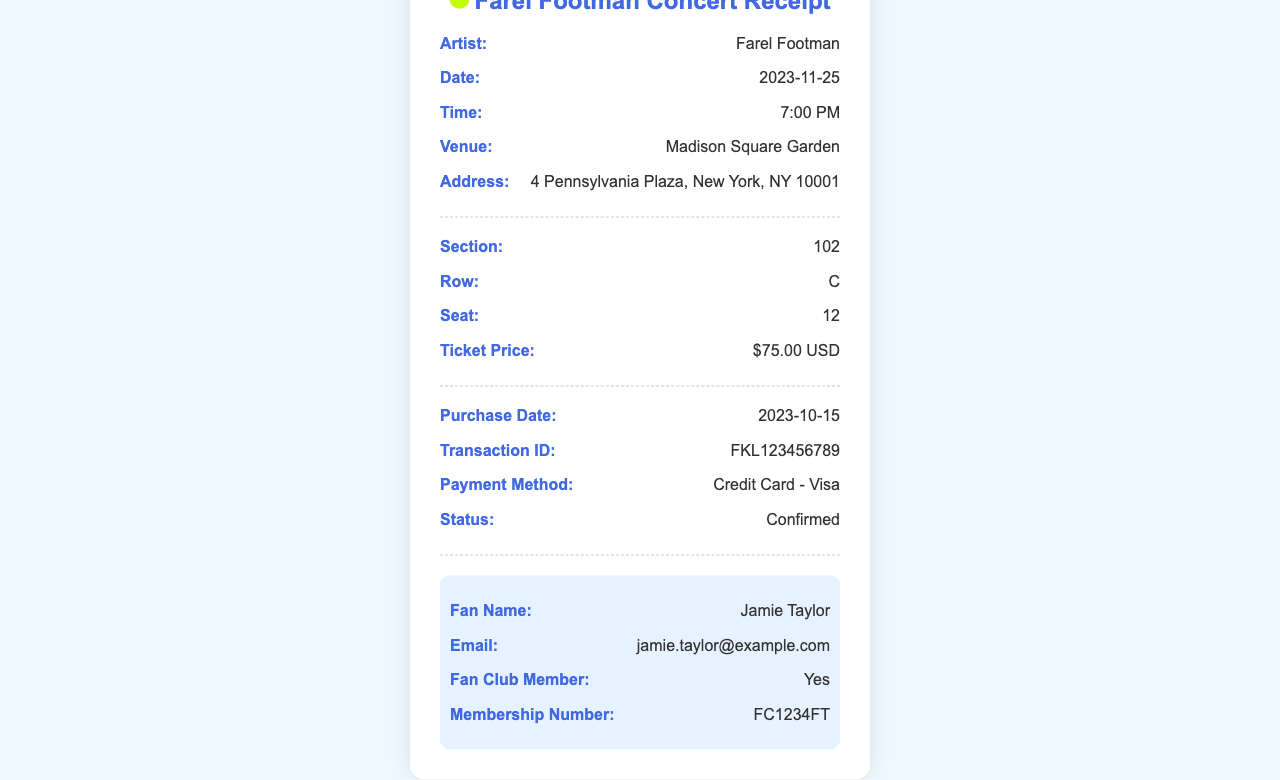What is the date of the concert? The concert date is specified in the document.
Answer: 2023-11-25 Where is the concert being held? The venue of the concert is listed in the document.
Answer: Madison Square Garden What is the seat number? The seat number is provided in the seating section of the receipt.
Answer: 12 What is the ticket price? The price is mentioned under the seating details.
Answer: $75.00 USD What is the transaction ID? The transaction ID is recorded in the purchase section.
Answer: FKL123456789 What method of payment was used? The payment method is specified in the document.
Answer: Credit Card - Visa Who is the fan name? The fan name is given in the fan info section.
Answer: Jamie Taylor Was the purchase confirmed? The status of the purchase is indicated in the receipt.
Answer: Confirmed What is the membership number? The membership number is provided in the fan info section.
Answer: FC1234FT 